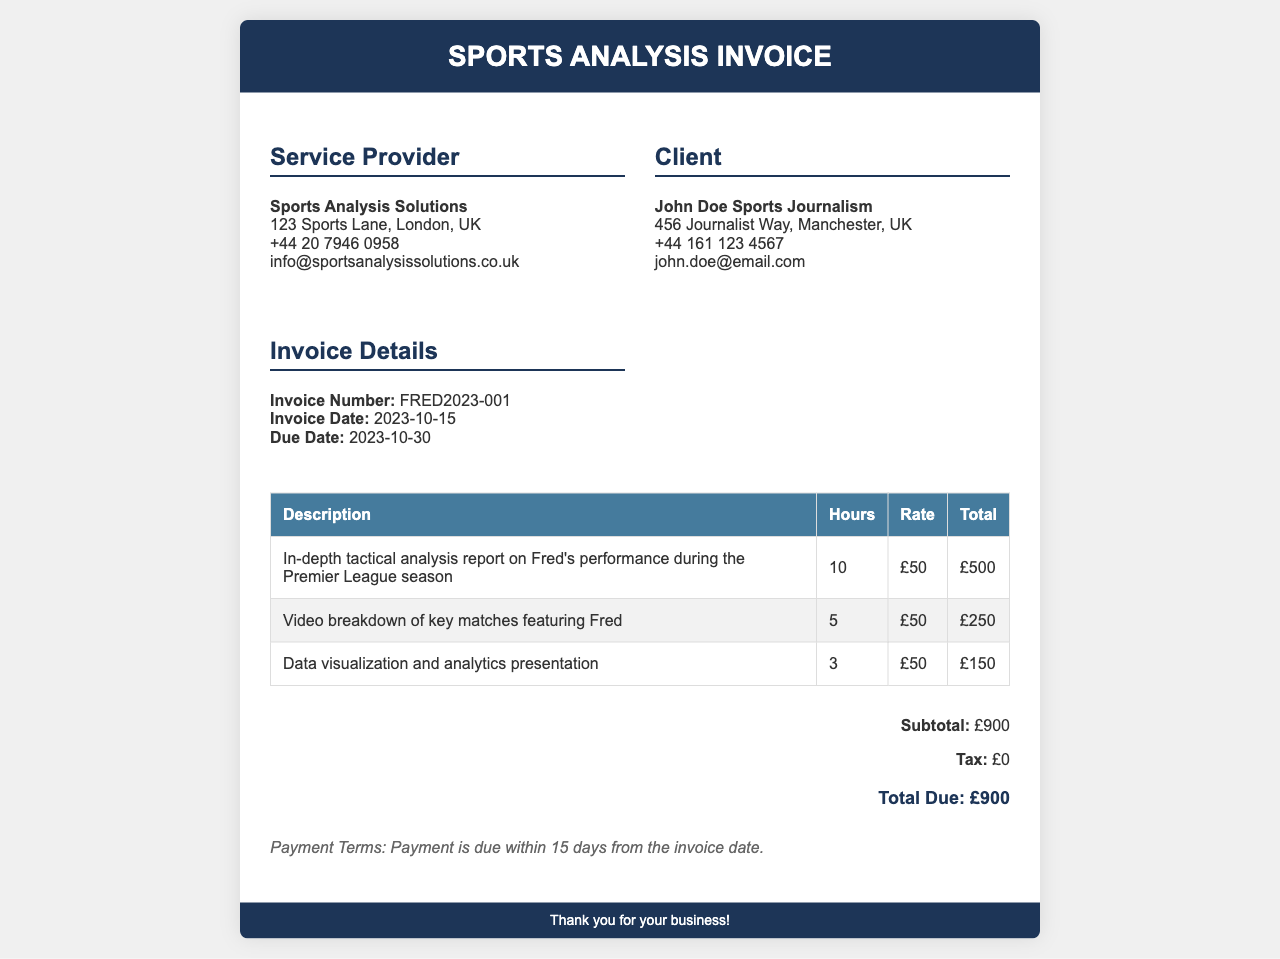What is the invoice number? The invoice number is a unique identifier for the invoice, which is specified in the document.
Answer: FRED2023-001 Who is the service provider? The service provider's name is listed in the invoice details section.
Answer: Sports Analysis Solutions What is the total due amount? The total due amount is provided at the end of the invoice, summarizing the overall cost.
Answer: £900 What is the due date for the payment? The due date indicates when the payment must be received and is shown in the invoice details.
Answer: 2023-10-30 How many hours were billed for the tactical analysis report? The number of hours reflects the time spent on a specific service and is mentioned in the services table.
Answer: 10 What services are included in the invoice? A summary or list of the services provided is available in the services table.
Answer: In-depth tactical analysis report on Fred's performance during the Premier League season, Video breakdown of key matches featuring Fred, Data visualization and analytics presentation What is the payment term stated in the document? The payment term outlines when payment is expected and is found in the payment terms section.
Answer: Payment is due within 15 days from the invoice date What is the tax amount applied to this invoice? The tax amount is listed directly in the invoice and contributes to the total calculated due.
Answer: £0 Who is the client? The client's name and details are provided in the invoice, indicating who is receiving the services.
Answer: John Doe Sports Journalism 